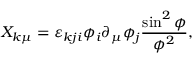<formula> <loc_0><loc_0><loc_500><loc_500>X _ { k \mu } = \varepsilon _ { k j i } \phi _ { i } \partial _ { \mu } \phi _ { j } \frac { \sin ^ { 2 } \phi } { \phi ^ { 2 } } ,</formula> 